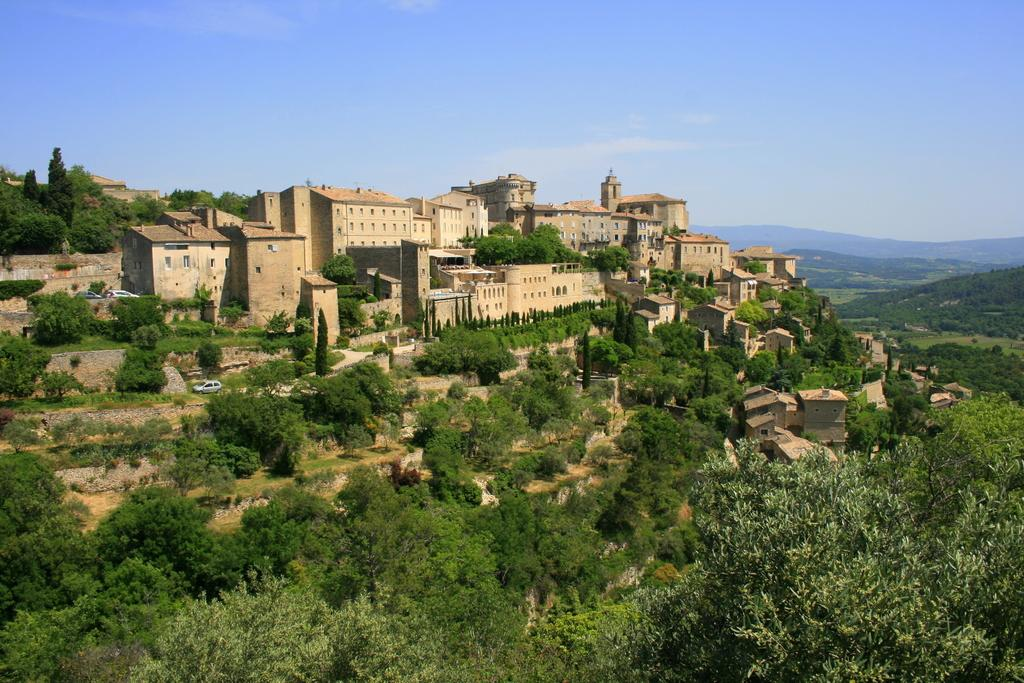What type of vegetation is at the bottom of the image? There are trees at the bottom of the image. What type of structures are in the middle of the image? There are buildings in the middle of the image. What is visible at the top of the image? The sky is visible at the top of the image. What type of skin can be seen on the trees in the image? There is no mention of the trees' skin in the image, as it is not a relevant detail. --- 